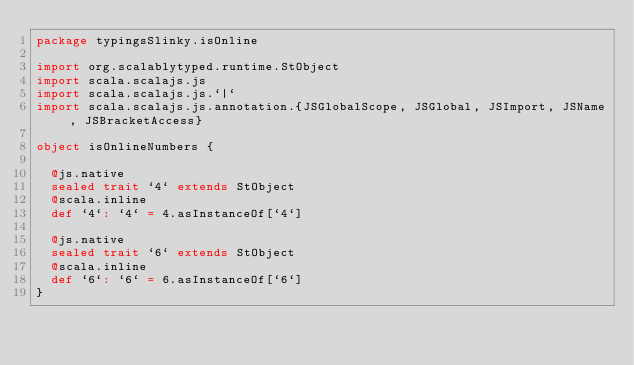Convert code to text. <code><loc_0><loc_0><loc_500><loc_500><_Scala_>package typingsSlinky.isOnline

import org.scalablytyped.runtime.StObject
import scala.scalajs.js
import scala.scalajs.js.`|`
import scala.scalajs.js.annotation.{JSGlobalScope, JSGlobal, JSImport, JSName, JSBracketAccess}

object isOnlineNumbers {
  
  @js.native
  sealed trait `4` extends StObject
  @scala.inline
  def `4`: `4` = 4.asInstanceOf[`4`]
  
  @js.native
  sealed trait `6` extends StObject
  @scala.inline
  def `6`: `6` = 6.asInstanceOf[`6`]
}
</code> 